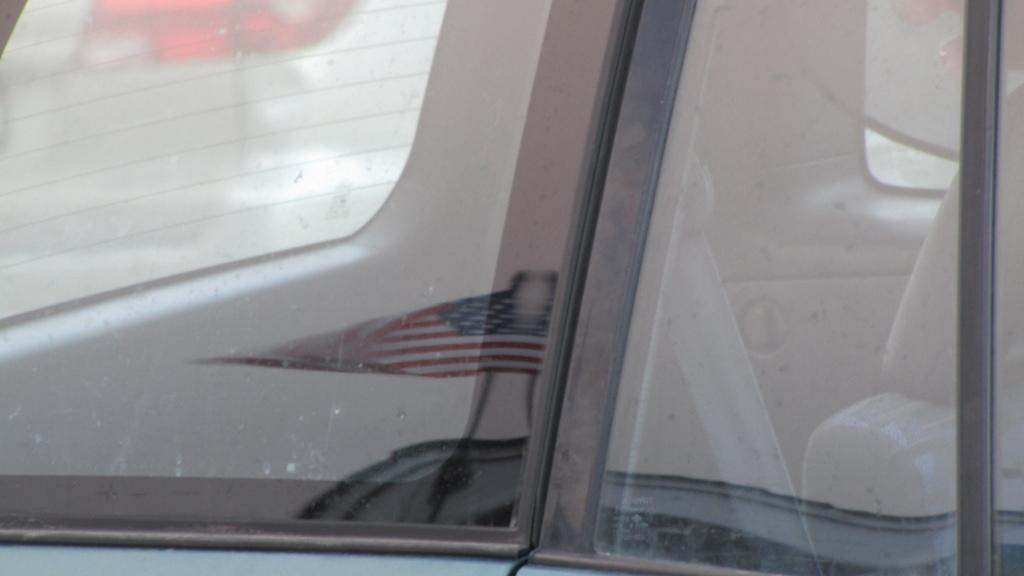What is the main subject of the image? The main subject of the image is a mirror of a vehicle. Is there any additional object attached to the mirror? Yes, there is a flag on the mirror. Are there any houses visible in the image? No, there are no houses present in the image. Can you see any cobwebs in the image? No, there are no cobwebs present in the image. 